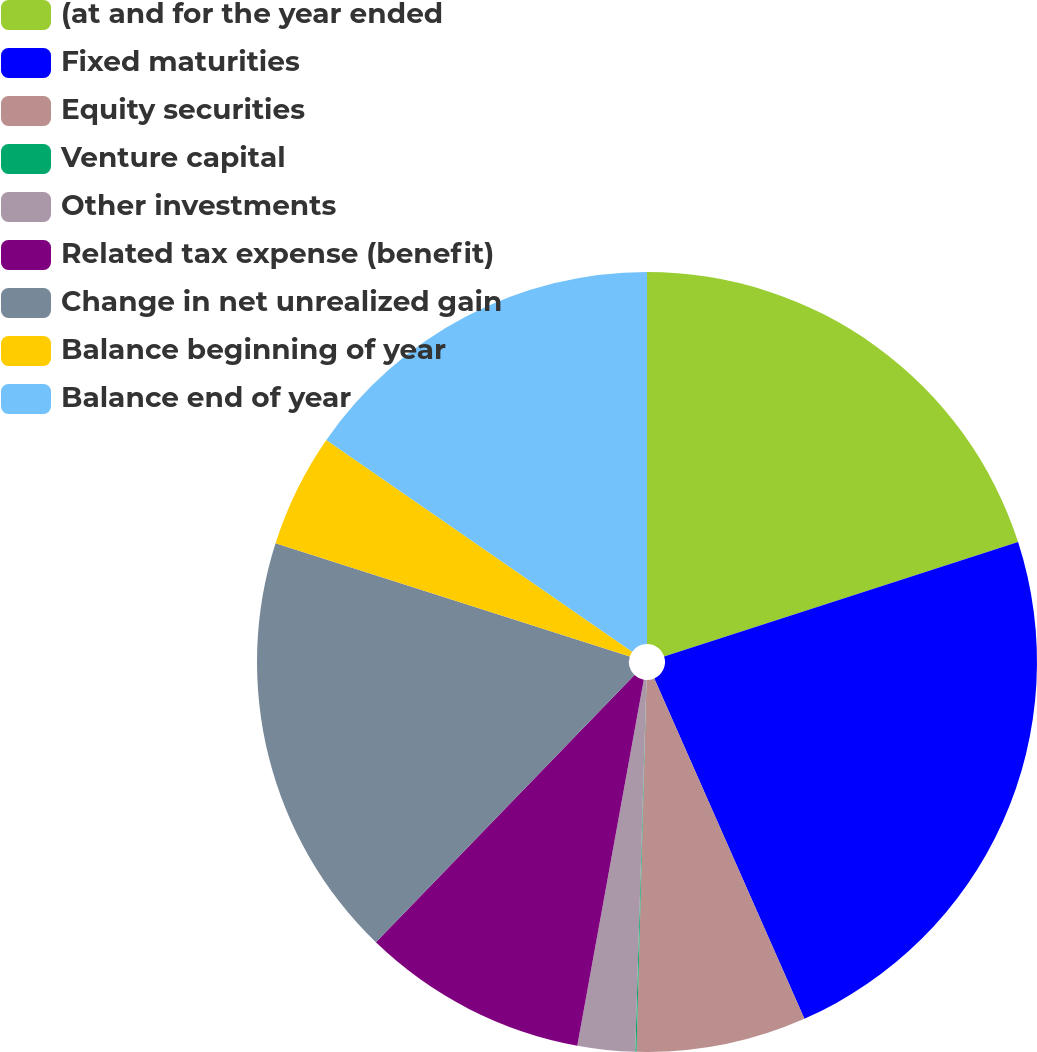<chart> <loc_0><loc_0><loc_500><loc_500><pie_chart><fcel>(at and for the year ended<fcel>Fixed maturities<fcel>Equity securities<fcel>Venture capital<fcel>Other investments<fcel>Related tax expense (benefit)<fcel>Change in net unrealized gain<fcel>Balance beginning of year<fcel>Balance end of year<nl><fcel>20.02%<fcel>23.36%<fcel>7.04%<fcel>0.05%<fcel>2.38%<fcel>9.37%<fcel>17.69%<fcel>4.71%<fcel>15.36%<nl></chart> 